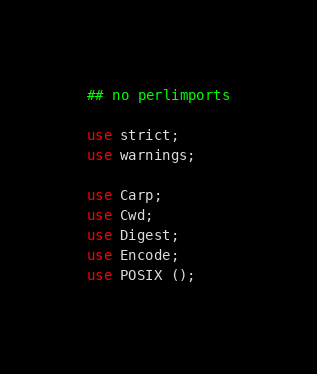Convert code to text. <code><loc_0><loc_0><loc_500><loc_500><_Perl_>## no perlimports

use strict;
use warnings;

use Carp;
use Cwd;
use Digest;
use Encode;
use POSIX ();
</code> 